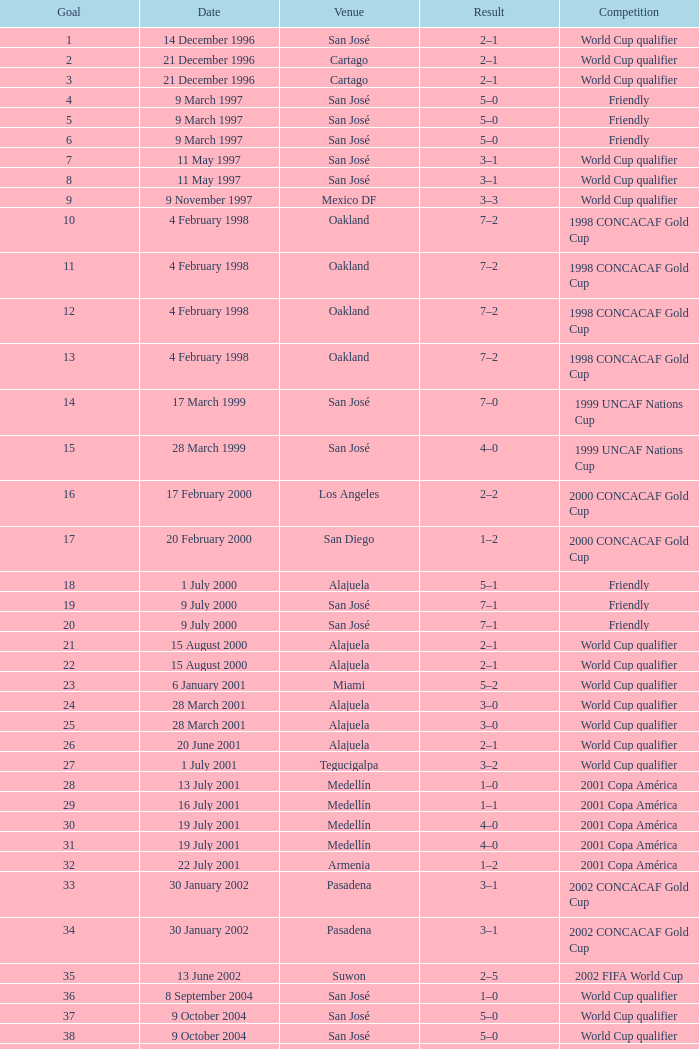What is the result in oakland? 7–2, 7–2, 7–2, 7–2. 